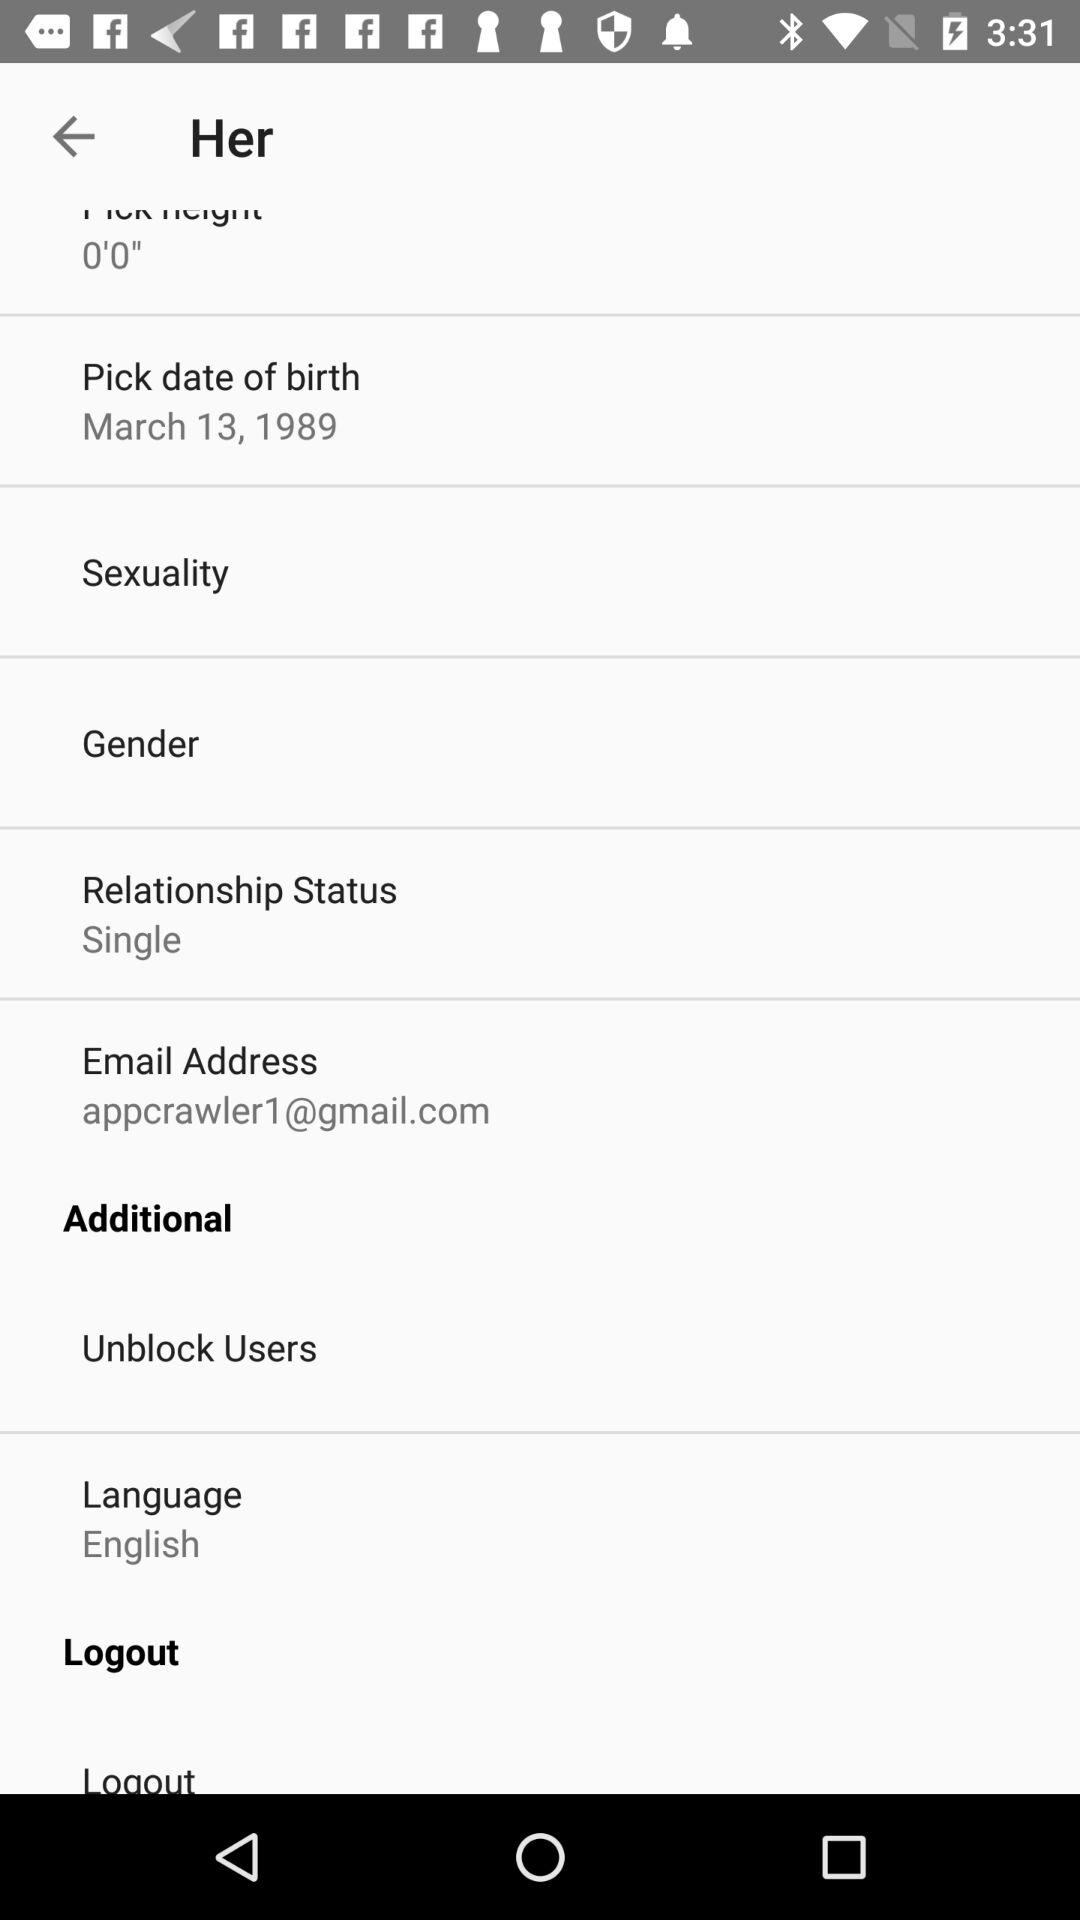What is the gender of the user?
When the provided information is insufficient, respond with <no answer>. <no answer> 